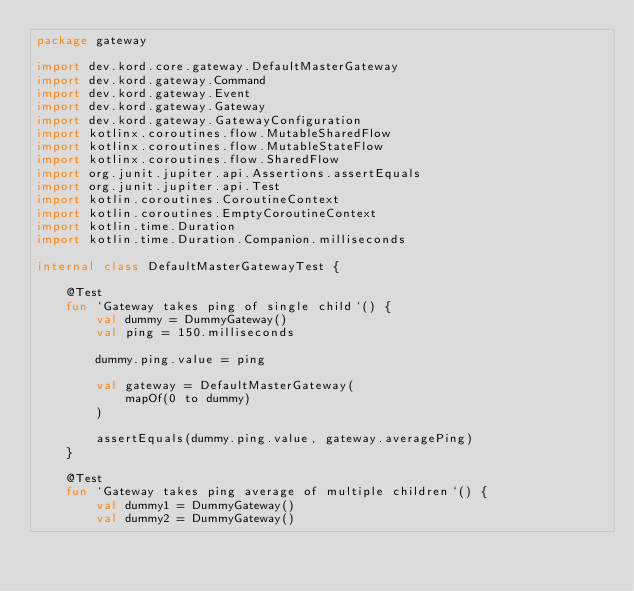<code> <loc_0><loc_0><loc_500><loc_500><_Kotlin_>package gateway

import dev.kord.core.gateway.DefaultMasterGateway
import dev.kord.gateway.Command
import dev.kord.gateway.Event
import dev.kord.gateway.Gateway
import dev.kord.gateway.GatewayConfiguration
import kotlinx.coroutines.flow.MutableSharedFlow
import kotlinx.coroutines.flow.MutableStateFlow
import kotlinx.coroutines.flow.SharedFlow
import org.junit.jupiter.api.Assertions.assertEquals
import org.junit.jupiter.api.Test
import kotlin.coroutines.CoroutineContext
import kotlin.coroutines.EmptyCoroutineContext
import kotlin.time.Duration
import kotlin.time.Duration.Companion.milliseconds

internal class DefaultMasterGatewayTest {

    @Test
    fun `Gateway takes ping of single child`() {
        val dummy = DummyGateway()
        val ping = 150.milliseconds

        dummy.ping.value = ping

        val gateway = DefaultMasterGateway(
            mapOf(0 to dummy)
        )

        assertEquals(dummy.ping.value, gateway.averagePing)
    }

    @Test
    fun `Gateway takes ping average of multiple children`() {
        val dummy1 = DummyGateway()
        val dummy2 = DummyGateway()</code> 